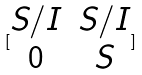<formula> <loc_0><loc_0><loc_500><loc_500>[ \begin{matrix} S / I & S / I \\ 0 & S \end{matrix} ]</formula> 